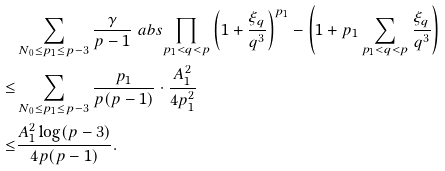Convert formula to latex. <formula><loc_0><loc_0><loc_500><loc_500>& \sum _ { N _ { 0 } \leq p _ { 1 } \leq p - 3 } \frac { \gamma } { p - 1 } \ a b s { \prod _ { p _ { 1 } < q < p } \left ( 1 + \frac { \xi _ { q } } { q ^ { 3 } } \right ) ^ { p _ { 1 } } - \left ( 1 + p _ { 1 } \sum _ { p _ { 1 } < q < p } \frac { \xi _ { q } } { q ^ { 3 } } \right ) } \\ \leq & \sum _ { N _ { 0 } \leq p _ { 1 } \leq p - 3 } \frac { p _ { 1 } } { p ( p - 1 ) } \cdot \frac { A _ { 1 } ^ { 2 } } { 4 p _ { 1 } ^ { 2 } } \\ \leq & \frac { A _ { 1 } ^ { 2 } \log ( p - 3 ) } { 4 p ( p - 1 ) } .</formula> 